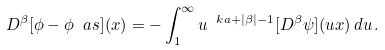Convert formula to latex. <formula><loc_0><loc_0><loc_500><loc_500>D ^ { \beta } [ \phi - \phi _ { \ } a s ] ( x ) = - \int _ { 1 } ^ { \infty } u ^ { \ k a + | \beta | - 1 } [ D ^ { \beta } \psi ] ( u x ) \, d u \, .</formula> 